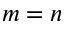Convert formula to latex. <formula><loc_0><loc_0><loc_500><loc_500>m = n</formula> 